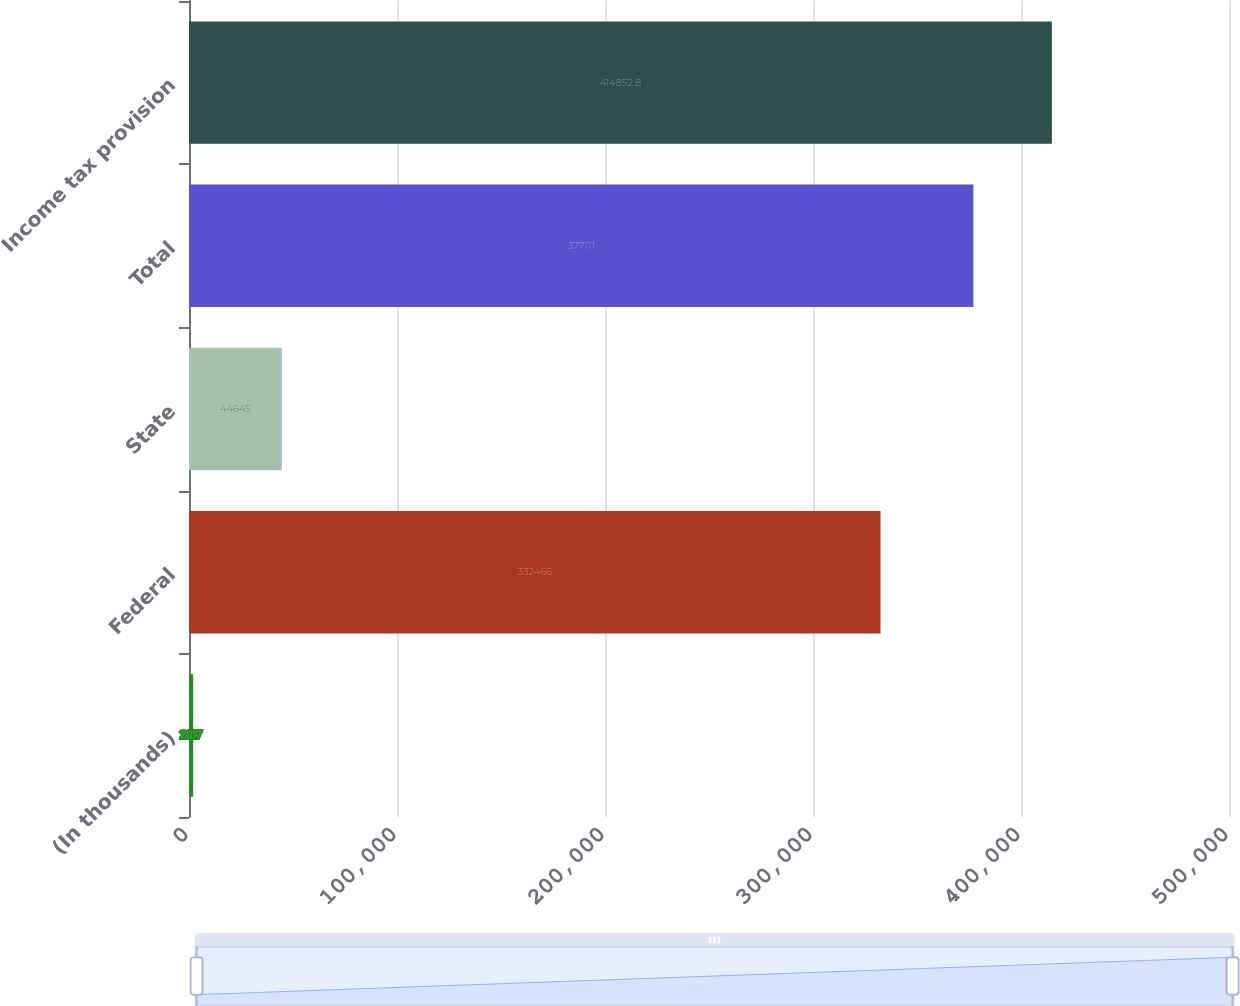Convert chart. <chart><loc_0><loc_0><loc_500><loc_500><bar_chart><fcel>(In thousands)<fcel>Federal<fcel>State<fcel>Total<fcel>Income tax provision<nl><fcel>2017<fcel>332466<fcel>44645<fcel>377111<fcel>414853<nl></chart> 